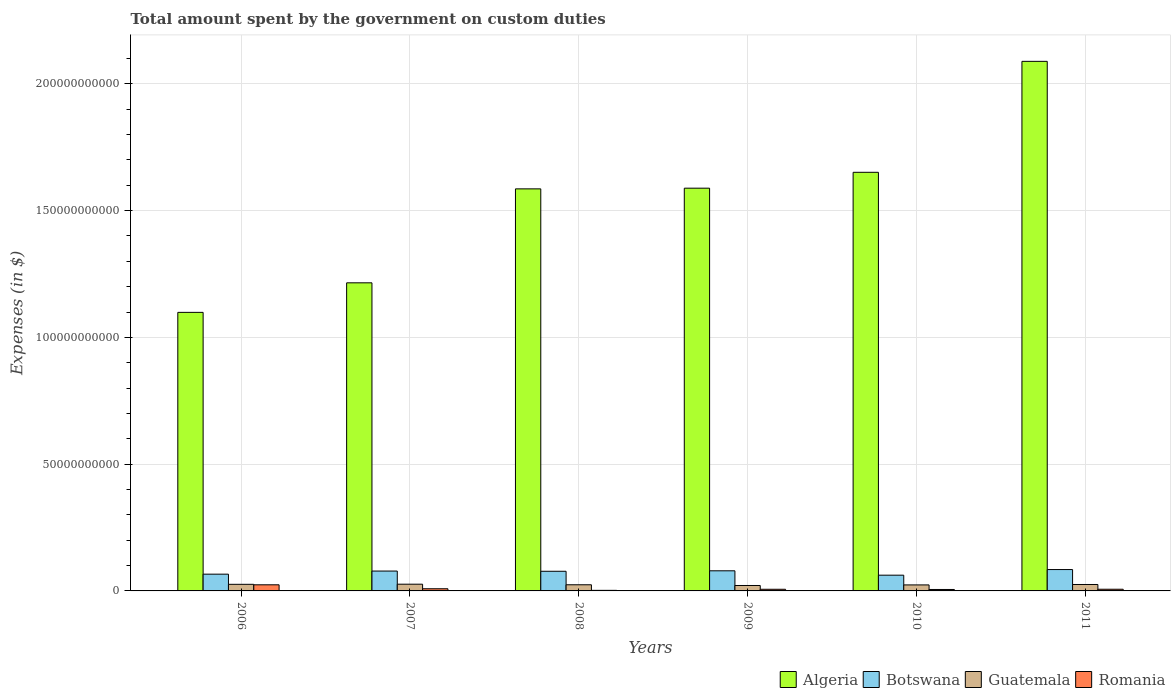How many different coloured bars are there?
Keep it short and to the point. 4. Are the number of bars per tick equal to the number of legend labels?
Give a very brief answer. Yes. How many bars are there on the 6th tick from the left?
Provide a succinct answer. 4. What is the label of the 4th group of bars from the left?
Your answer should be very brief. 2009. What is the amount spent on custom duties by the government in Guatemala in 2011?
Make the answer very short. 2.53e+09. Across all years, what is the maximum amount spent on custom duties by the government in Romania?
Keep it short and to the point. 2.41e+09. Across all years, what is the minimum amount spent on custom duties by the government in Algeria?
Ensure brevity in your answer.  1.10e+11. In which year was the amount spent on custom duties by the government in Botswana maximum?
Your answer should be very brief. 2011. What is the total amount spent on custom duties by the government in Algeria in the graph?
Offer a very short reply. 9.23e+11. What is the difference between the amount spent on custom duties by the government in Algeria in 2010 and that in 2011?
Offer a very short reply. -4.38e+1. What is the difference between the amount spent on custom duties by the government in Guatemala in 2011 and the amount spent on custom duties by the government in Algeria in 2006?
Provide a short and direct response. -1.07e+11. What is the average amount spent on custom duties by the government in Botswana per year?
Make the answer very short. 7.46e+09. In the year 2008, what is the difference between the amount spent on custom duties by the government in Guatemala and amount spent on custom duties by the government in Algeria?
Offer a very short reply. -1.56e+11. What is the ratio of the amount spent on custom duties by the government in Romania in 2008 to that in 2009?
Provide a succinct answer. 0.35. Is the amount spent on custom duties by the government in Algeria in 2006 less than that in 2009?
Your answer should be compact. Yes. What is the difference between the highest and the second highest amount spent on custom duties by the government in Algeria?
Give a very brief answer. 4.38e+1. What is the difference between the highest and the lowest amount spent on custom duties by the government in Botswana?
Keep it short and to the point. 2.22e+09. In how many years, is the amount spent on custom duties by the government in Guatemala greater than the average amount spent on custom duties by the government in Guatemala taken over all years?
Keep it short and to the point. 3. What does the 1st bar from the left in 2009 represents?
Provide a short and direct response. Algeria. What does the 1st bar from the right in 2010 represents?
Offer a very short reply. Romania. Is it the case that in every year, the sum of the amount spent on custom duties by the government in Botswana and amount spent on custom duties by the government in Romania is greater than the amount spent on custom duties by the government in Guatemala?
Provide a succinct answer. Yes. How many bars are there?
Provide a short and direct response. 24. Are all the bars in the graph horizontal?
Ensure brevity in your answer.  No. How many years are there in the graph?
Provide a short and direct response. 6. Are the values on the major ticks of Y-axis written in scientific E-notation?
Give a very brief answer. No. Does the graph contain grids?
Your answer should be compact. Yes. Where does the legend appear in the graph?
Keep it short and to the point. Bottom right. How many legend labels are there?
Provide a short and direct response. 4. What is the title of the graph?
Provide a succinct answer. Total amount spent by the government on custom duties. What is the label or title of the X-axis?
Offer a terse response. Years. What is the label or title of the Y-axis?
Ensure brevity in your answer.  Expenses (in $). What is the Expenses (in $) in Algeria in 2006?
Provide a succinct answer. 1.10e+11. What is the Expenses (in $) of Botswana in 2006?
Your answer should be compact. 6.61e+09. What is the Expenses (in $) in Guatemala in 2006?
Keep it short and to the point. 2.60e+09. What is the Expenses (in $) of Romania in 2006?
Your answer should be very brief. 2.41e+09. What is the Expenses (in $) in Algeria in 2007?
Provide a short and direct response. 1.22e+11. What is the Expenses (in $) in Botswana in 2007?
Give a very brief answer. 7.83e+09. What is the Expenses (in $) of Guatemala in 2007?
Ensure brevity in your answer.  2.65e+09. What is the Expenses (in $) of Romania in 2007?
Offer a terse response. 8.56e+08. What is the Expenses (in $) of Algeria in 2008?
Your answer should be compact. 1.59e+11. What is the Expenses (in $) in Botswana in 2008?
Provide a succinct answer. 7.75e+09. What is the Expenses (in $) in Guatemala in 2008?
Keep it short and to the point. 2.43e+09. What is the Expenses (in $) in Romania in 2008?
Offer a very short reply. 2.28e+08. What is the Expenses (in $) in Algeria in 2009?
Offer a terse response. 1.59e+11. What is the Expenses (in $) in Botswana in 2009?
Your answer should be compact. 7.93e+09. What is the Expenses (in $) in Guatemala in 2009?
Provide a short and direct response. 2.14e+09. What is the Expenses (in $) in Romania in 2009?
Your answer should be very brief. 6.50e+08. What is the Expenses (in $) of Algeria in 2010?
Provide a short and direct response. 1.65e+11. What is the Expenses (in $) in Botswana in 2010?
Give a very brief answer. 6.21e+09. What is the Expenses (in $) of Guatemala in 2010?
Keep it short and to the point. 2.37e+09. What is the Expenses (in $) in Romania in 2010?
Provide a short and direct response. 5.69e+08. What is the Expenses (in $) in Algeria in 2011?
Provide a short and direct response. 2.09e+11. What is the Expenses (in $) in Botswana in 2011?
Your answer should be very brief. 8.42e+09. What is the Expenses (in $) of Guatemala in 2011?
Give a very brief answer. 2.53e+09. What is the Expenses (in $) of Romania in 2011?
Offer a very short reply. 6.61e+08. Across all years, what is the maximum Expenses (in $) of Algeria?
Provide a short and direct response. 2.09e+11. Across all years, what is the maximum Expenses (in $) in Botswana?
Provide a short and direct response. 8.42e+09. Across all years, what is the maximum Expenses (in $) in Guatemala?
Keep it short and to the point. 2.65e+09. Across all years, what is the maximum Expenses (in $) in Romania?
Your response must be concise. 2.41e+09. Across all years, what is the minimum Expenses (in $) in Algeria?
Give a very brief answer. 1.10e+11. Across all years, what is the minimum Expenses (in $) of Botswana?
Your answer should be very brief. 6.21e+09. Across all years, what is the minimum Expenses (in $) of Guatemala?
Give a very brief answer. 2.14e+09. Across all years, what is the minimum Expenses (in $) in Romania?
Offer a terse response. 2.28e+08. What is the total Expenses (in $) of Algeria in the graph?
Offer a terse response. 9.23e+11. What is the total Expenses (in $) in Botswana in the graph?
Provide a short and direct response. 4.48e+1. What is the total Expenses (in $) in Guatemala in the graph?
Make the answer very short. 1.47e+1. What is the total Expenses (in $) in Romania in the graph?
Offer a terse response. 5.38e+09. What is the difference between the Expenses (in $) of Algeria in 2006 and that in 2007?
Ensure brevity in your answer.  -1.16e+1. What is the difference between the Expenses (in $) of Botswana in 2006 and that in 2007?
Make the answer very short. -1.22e+09. What is the difference between the Expenses (in $) in Guatemala in 2006 and that in 2007?
Keep it short and to the point. -5.04e+07. What is the difference between the Expenses (in $) in Romania in 2006 and that in 2007?
Ensure brevity in your answer.  1.56e+09. What is the difference between the Expenses (in $) in Algeria in 2006 and that in 2008?
Your answer should be compact. -4.87e+1. What is the difference between the Expenses (in $) in Botswana in 2006 and that in 2008?
Keep it short and to the point. -1.14e+09. What is the difference between the Expenses (in $) of Guatemala in 2006 and that in 2008?
Provide a succinct answer. 1.76e+08. What is the difference between the Expenses (in $) in Romania in 2006 and that in 2008?
Ensure brevity in your answer.  2.19e+09. What is the difference between the Expenses (in $) in Algeria in 2006 and that in 2009?
Your answer should be very brief. -4.90e+1. What is the difference between the Expenses (in $) of Botswana in 2006 and that in 2009?
Your response must be concise. -1.32e+09. What is the difference between the Expenses (in $) of Guatemala in 2006 and that in 2009?
Keep it short and to the point. 4.65e+08. What is the difference between the Expenses (in $) in Romania in 2006 and that in 2009?
Your answer should be compact. 1.76e+09. What is the difference between the Expenses (in $) in Algeria in 2006 and that in 2010?
Provide a succinct answer. -5.52e+1. What is the difference between the Expenses (in $) of Botswana in 2006 and that in 2010?
Your answer should be compact. 4.04e+08. What is the difference between the Expenses (in $) in Guatemala in 2006 and that in 2010?
Offer a very short reply. 2.36e+08. What is the difference between the Expenses (in $) of Romania in 2006 and that in 2010?
Provide a succinct answer. 1.85e+09. What is the difference between the Expenses (in $) in Algeria in 2006 and that in 2011?
Provide a succinct answer. -9.90e+1. What is the difference between the Expenses (in $) in Botswana in 2006 and that in 2011?
Keep it short and to the point. -1.81e+09. What is the difference between the Expenses (in $) of Guatemala in 2006 and that in 2011?
Give a very brief answer. 7.09e+07. What is the difference between the Expenses (in $) of Romania in 2006 and that in 2011?
Offer a terse response. 1.75e+09. What is the difference between the Expenses (in $) in Algeria in 2007 and that in 2008?
Ensure brevity in your answer.  -3.71e+1. What is the difference between the Expenses (in $) of Botswana in 2007 and that in 2008?
Your answer should be very brief. 8.47e+07. What is the difference between the Expenses (in $) of Guatemala in 2007 and that in 2008?
Offer a very short reply. 2.27e+08. What is the difference between the Expenses (in $) of Romania in 2007 and that in 2008?
Provide a short and direct response. 6.28e+08. What is the difference between the Expenses (in $) in Algeria in 2007 and that in 2009?
Ensure brevity in your answer.  -3.73e+1. What is the difference between the Expenses (in $) in Botswana in 2007 and that in 2009?
Make the answer very short. -9.62e+07. What is the difference between the Expenses (in $) of Guatemala in 2007 and that in 2009?
Offer a very short reply. 5.15e+08. What is the difference between the Expenses (in $) in Romania in 2007 and that in 2009?
Provide a succinct answer. 2.05e+08. What is the difference between the Expenses (in $) in Algeria in 2007 and that in 2010?
Give a very brief answer. -4.36e+1. What is the difference between the Expenses (in $) in Botswana in 2007 and that in 2010?
Give a very brief answer. 1.63e+09. What is the difference between the Expenses (in $) in Guatemala in 2007 and that in 2010?
Your response must be concise. 2.86e+08. What is the difference between the Expenses (in $) in Romania in 2007 and that in 2010?
Your response must be concise. 2.87e+08. What is the difference between the Expenses (in $) of Algeria in 2007 and that in 2011?
Offer a terse response. -8.73e+1. What is the difference between the Expenses (in $) of Botswana in 2007 and that in 2011?
Offer a terse response. -5.89e+08. What is the difference between the Expenses (in $) in Guatemala in 2007 and that in 2011?
Offer a terse response. 1.21e+08. What is the difference between the Expenses (in $) in Romania in 2007 and that in 2011?
Provide a succinct answer. 1.95e+08. What is the difference between the Expenses (in $) of Algeria in 2008 and that in 2009?
Provide a short and direct response. -2.69e+08. What is the difference between the Expenses (in $) in Botswana in 2008 and that in 2009?
Give a very brief answer. -1.81e+08. What is the difference between the Expenses (in $) in Guatemala in 2008 and that in 2009?
Keep it short and to the point. 2.88e+08. What is the difference between the Expenses (in $) of Romania in 2008 and that in 2009?
Give a very brief answer. -4.23e+08. What is the difference between the Expenses (in $) in Algeria in 2008 and that in 2010?
Ensure brevity in your answer.  -6.53e+09. What is the difference between the Expenses (in $) in Botswana in 2008 and that in 2010?
Your response must be concise. 1.54e+09. What is the difference between the Expenses (in $) of Guatemala in 2008 and that in 2010?
Offer a terse response. 5.95e+07. What is the difference between the Expenses (in $) in Romania in 2008 and that in 2010?
Your answer should be very brief. -3.41e+08. What is the difference between the Expenses (in $) in Algeria in 2008 and that in 2011?
Give a very brief answer. -5.03e+1. What is the difference between the Expenses (in $) of Botswana in 2008 and that in 2011?
Make the answer very short. -6.74e+08. What is the difference between the Expenses (in $) in Guatemala in 2008 and that in 2011?
Your answer should be very brief. -1.05e+08. What is the difference between the Expenses (in $) of Romania in 2008 and that in 2011?
Keep it short and to the point. -4.33e+08. What is the difference between the Expenses (in $) in Algeria in 2009 and that in 2010?
Offer a terse response. -6.26e+09. What is the difference between the Expenses (in $) in Botswana in 2009 and that in 2010?
Provide a short and direct response. 1.72e+09. What is the difference between the Expenses (in $) of Guatemala in 2009 and that in 2010?
Your response must be concise. -2.29e+08. What is the difference between the Expenses (in $) in Romania in 2009 and that in 2010?
Ensure brevity in your answer.  8.18e+07. What is the difference between the Expenses (in $) of Algeria in 2009 and that in 2011?
Make the answer very short. -5.00e+1. What is the difference between the Expenses (in $) of Botswana in 2009 and that in 2011?
Make the answer very short. -4.93e+08. What is the difference between the Expenses (in $) in Guatemala in 2009 and that in 2011?
Your answer should be compact. -3.94e+08. What is the difference between the Expenses (in $) in Romania in 2009 and that in 2011?
Give a very brief answer. -1.02e+07. What is the difference between the Expenses (in $) in Algeria in 2010 and that in 2011?
Offer a terse response. -4.38e+1. What is the difference between the Expenses (in $) of Botswana in 2010 and that in 2011?
Offer a terse response. -2.22e+09. What is the difference between the Expenses (in $) in Guatemala in 2010 and that in 2011?
Provide a short and direct response. -1.65e+08. What is the difference between the Expenses (in $) in Romania in 2010 and that in 2011?
Give a very brief answer. -9.20e+07. What is the difference between the Expenses (in $) of Algeria in 2006 and the Expenses (in $) of Botswana in 2007?
Your response must be concise. 1.02e+11. What is the difference between the Expenses (in $) in Algeria in 2006 and the Expenses (in $) in Guatemala in 2007?
Offer a very short reply. 1.07e+11. What is the difference between the Expenses (in $) in Algeria in 2006 and the Expenses (in $) in Romania in 2007?
Give a very brief answer. 1.09e+11. What is the difference between the Expenses (in $) in Botswana in 2006 and the Expenses (in $) in Guatemala in 2007?
Your response must be concise. 3.96e+09. What is the difference between the Expenses (in $) of Botswana in 2006 and the Expenses (in $) of Romania in 2007?
Give a very brief answer. 5.75e+09. What is the difference between the Expenses (in $) of Guatemala in 2006 and the Expenses (in $) of Romania in 2007?
Provide a short and direct response. 1.75e+09. What is the difference between the Expenses (in $) in Algeria in 2006 and the Expenses (in $) in Botswana in 2008?
Provide a succinct answer. 1.02e+11. What is the difference between the Expenses (in $) in Algeria in 2006 and the Expenses (in $) in Guatemala in 2008?
Make the answer very short. 1.07e+11. What is the difference between the Expenses (in $) in Algeria in 2006 and the Expenses (in $) in Romania in 2008?
Keep it short and to the point. 1.10e+11. What is the difference between the Expenses (in $) of Botswana in 2006 and the Expenses (in $) of Guatemala in 2008?
Your response must be concise. 4.18e+09. What is the difference between the Expenses (in $) in Botswana in 2006 and the Expenses (in $) in Romania in 2008?
Offer a very short reply. 6.38e+09. What is the difference between the Expenses (in $) in Guatemala in 2006 and the Expenses (in $) in Romania in 2008?
Make the answer very short. 2.38e+09. What is the difference between the Expenses (in $) in Algeria in 2006 and the Expenses (in $) in Botswana in 2009?
Ensure brevity in your answer.  1.02e+11. What is the difference between the Expenses (in $) in Algeria in 2006 and the Expenses (in $) in Guatemala in 2009?
Your response must be concise. 1.08e+11. What is the difference between the Expenses (in $) of Algeria in 2006 and the Expenses (in $) of Romania in 2009?
Ensure brevity in your answer.  1.09e+11. What is the difference between the Expenses (in $) in Botswana in 2006 and the Expenses (in $) in Guatemala in 2009?
Give a very brief answer. 4.47e+09. What is the difference between the Expenses (in $) in Botswana in 2006 and the Expenses (in $) in Romania in 2009?
Offer a very short reply. 5.96e+09. What is the difference between the Expenses (in $) in Guatemala in 2006 and the Expenses (in $) in Romania in 2009?
Ensure brevity in your answer.  1.95e+09. What is the difference between the Expenses (in $) in Algeria in 2006 and the Expenses (in $) in Botswana in 2010?
Provide a short and direct response. 1.04e+11. What is the difference between the Expenses (in $) in Algeria in 2006 and the Expenses (in $) in Guatemala in 2010?
Your answer should be very brief. 1.07e+11. What is the difference between the Expenses (in $) in Algeria in 2006 and the Expenses (in $) in Romania in 2010?
Provide a succinct answer. 1.09e+11. What is the difference between the Expenses (in $) in Botswana in 2006 and the Expenses (in $) in Guatemala in 2010?
Offer a very short reply. 4.24e+09. What is the difference between the Expenses (in $) in Botswana in 2006 and the Expenses (in $) in Romania in 2010?
Keep it short and to the point. 6.04e+09. What is the difference between the Expenses (in $) of Guatemala in 2006 and the Expenses (in $) of Romania in 2010?
Ensure brevity in your answer.  2.03e+09. What is the difference between the Expenses (in $) in Algeria in 2006 and the Expenses (in $) in Botswana in 2011?
Give a very brief answer. 1.01e+11. What is the difference between the Expenses (in $) of Algeria in 2006 and the Expenses (in $) of Guatemala in 2011?
Ensure brevity in your answer.  1.07e+11. What is the difference between the Expenses (in $) of Algeria in 2006 and the Expenses (in $) of Romania in 2011?
Ensure brevity in your answer.  1.09e+11. What is the difference between the Expenses (in $) in Botswana in 2006 and the Expenses (in $) in Guatemala in 2011?
Offer a terse response. 4.08e+09. What is the difference between the Expenses (in $) in Botswana in 2006 and the Expenses (in $) in Romania in 2011?
Keep it short and to the point. 5.95e+09. What is the difference between the Expenses (in $) of Guatemala in 2006 and the Expenses (in $) of Romania in 2011?
Your response must be concise. 1.94e+09. What is the difference between the Expenses (in $) of Algeria in 2007 and the Expenses (in $) of Botswana in 2008?
Your answer should be compact. 1.14e+11. What is the difference between the Expenses (in $) in Algeria in 2007 and the Expenses (in $) in Guatemala in 2008?
Provide a succinct answer. 1.19e+11. What is the difference between the Expenses (in $) of Algeria in 2007 and the Expenses (in $) of Romania in 2008?
Ensure brevity in your answer.  1.21e+11. What is the difference between the Expenses (in $) of Botswana in 2007 and the Expenses (in $) of Guatemala in 2008?
Your response must be concise. 5.41e+09. What is the difference between the Expenses (in $) of Botswana in 2007 and the Expenses (in $) of Romania in 2008?
Offer a very short reply. 7.61e+09. What is the difference between the Expenses (in $) in Guatemala in 2007 and the Expenses (in $) in Romania in 2008?
Keep it short and to the point. 2.43e+09. What is the difference between the Expenses (in $) of Algeria in 2007 and the Expenses (in $) of Botswana in 2009?
Your answer should be compact. 1.14e+11. What is the difference between the Expenses (in $) of Algeria in 2007 and the Expenses (in $) of Guatemala in 2009?
Keep it short and to the point. 1.19e+11. What is the difference between the Expenses (in $) of Algeria in 2007 and the Expenses (in $) of Romania in 2009?
Provide a short and direct response. 1.21e+11. What is the difference between the Expenses (in $) of Botswana in 2007 and the Expenses (in $) of Guatemala in 2009?
Provide a short and direct response. 5.70e+09. What is the difference between the Expenses (in $) in Botswana in 2007 and the Expenses (in $) in Romania in 2009?
Ensure brevity in your answer.  7.18e+09. What is the difference between the Expenses (in $) of Guatemala in 2007 and the Expenses (in $) of Romania in 2009?
Keep it short and to the point. 2.00e+09. What is the difference between the Expenses (in $) in Algeria in 2007 and the Expenses (in $) in Botswana in 2010?
Make the answer very short. 1.15e+11. What is the difference between the Expenses (in $) of Algeria in 2007 and the Expenses (in $) of Guatemala in 2010?
Your answer should be compact. 1.19e+11. What is the difference between the Expenses (in $) in Algeria in 2007 and the Expenses (in $) in Romania in 2010?
Provide a short and direct response. 1.21e+11. What is the difference between the Expenses (in $) in Botswana in 2007 and the Expenses (in $) in Guatemala in 2010?
Keep it short and to the point. 5.47e+09. What is the difference between the Expenses (in $) of Botswana in 2007 and the Expenses (in $) of Romania in 2010?
Offer a terse response. 7.27e+09. What is the difference between the Expenses (in $) of Guatemala in 2007 and the Expenses (in $) of Romania in 2010?
Your answer should be compact. 2.09e+09. What is the difference between the Expenses (in $) in Algeria in 2007 and the Expenses (in $) in Botswana in 2011?
Offer a very short reply. 1.13e+11. What is the difference between the Expenses (in $) in Algeria in 2007 and the Expenses (in $) in Guatemala in 2011?
Offer a terse response. 1.19e+11. What is the difference between the Expenses (in $) in Algeria in 2007 and the Expenses (in $) in Romania in 2011?
Give a very brief answer. 1.21e+11. What is the difference between the Expenses (in $) of Botswana in 2007 and the Expenses (in $) of Guatemala in 2011?
Your answer should be compact. 5.30e+09. What is the difference between the Expenses (in $) in Botswana in 2007 and the Expenses (in $) in Romania in 2011?
Offer a terse response. 7.17e+09. What is the difference between the Expenses (in $) of Guatemala in 2007 and the Expenses (in $) of Romania in 2011?
Your answer should be compact. 1.99e+09. What is the difference between the Expenses (in $) of Algeria in 2008 and the Expenses (in $) of Botswana in 2009?
Offer a terse response. 1.51e+11. What is the difference between the Expenses (in $) of Algeria in 2008 and the Expenses (in $) of Guatemala in 2009?
Make the answer very short. 1.56e+11. What is the difference between the Expenses (in $) of Algeria in 2008 and the Expenses (in $) of Romania in 2009?
Your answer should be very brief. 1.58e+11. What is the difference between the Expenses (in $) in Botswana in 2008 and the Expenses (in $) in Guatemala in 2009?
Your answer should be compact. 5.61e+09. What is the difference between the Expenses (in $) of Botswana in 2008 and the Expenses (in $) of Romania in 2009?
Provide a succinct answer. 7.10e+09. What is the difference between the Expenses (in $) in Guatemala in 2008 and the Expenses (in $) in Romania in 2009?
Provide a short and direct response. 1.78e+09. What is the difference between the Expenses (in $) of Algeria in 2008 and the Expenses (in $) of Botswana in 2010?
Keep it short and to the point. 1.52e+11. What is the difference between the Expenses (in $) of Algeria in 2008 and the Expenses (in $) of Guatemala in 2010?
Provide a succinct answer. 1.56e+11. What is the difference between the Expenses (in $) of Algeria in 2008 and the Expenses (in $) of Romania in 2010?
Provide a short and direct response. 1.58e+11. What is the difference between the Expenses (in $) of Botswana in 2008 and the Expenses (in $) of Guatemala in 2010?
Offer a very short reply. 5.38e+09. What is the difference between the Expenses (in $) of Botswana in 2008 and the Expenses (in $) of Romania in 2010?
Provide a succinct answer. 7.18e+09. What is the difference between the Expenses (in $) of Guatemala in 2008 and the Expenses (in $) of Romania in 2010?
Make the answer very short. 1.86e+09. What is the difference between the Expenses (in $) of Algeria in 2008 and the Expenses (in $) of Botswana in 2011?
Your answer should be compact. 1.50e+11. What is the difference between the Expenses (in $) of Algeria in 2008 and the Expenses (in $) of Guatemala in 2011?
Keep it short and to the point. 1.56e+11. What is the difference between the Expenses (in $) of Algeria in 2008 and the Expenses (in $) of Romania in 2011?
Offer a terse response. 1.58e+11. What is the difference between the Expenses (in $) of Botswana in 2008 and the Expenses (in $) of Guatemala in 2011?
Make the answer very short. 5.22e+09. What is the difference between the Expenses (in $) in Botswana in 2008 and the Expenses (in $) in Romania in 2011?
Your response must be concise. 7.09e+09. What is the difference between the Expenses (in $) of Guatemala in 2008 and the Expenses (in $) of Romania in 2011?
Make the answer very short. 1.77e+09. What is the difference between the Expenses (in $) in Algeria in 2009 and the Expenses (in $) in Botswana in 2010?
Give a very brief answer. 1.53e+11. What is the difference between the Expenses (in $) in Algeria in 2009 and the Expenses (in $) in Guatemala in 2010?
Your answer should be very brief. 1.56e+11. What is the difference between the Expenses (in $) in Algeria in 2009 and the Expenses (in $) in Romania in 2010?
Your answer should be very brief. 1.58e+11. What is the difference between the Expenses (in $) of Botswana in 2009 and the Expenses (in $) of Guatemala in 2010?
Your answer should be compact. 5.56e+09. What is the difference between the Expenses (in $) in Botswana in 2009 and the Expenses (in $) in Romania in 2010?
Provide a succinct answer. 7.36e+09. What is the difference between the Expenses (in $) in Guatemala in 2009 and the Expenses (in $) in Romania in 2010?
Your answer should be very brief. 1.57e+09. What is the difference between the Expenses (in $) of Algeria in 2009 and the Expenses (in $) of Botswana in 2011?
Ensure brevity in your answer.  1.50e+11. What is the difference between the Expenses (in $) of Algeria in 2009 and the Expenses (in $) of Guatemala in 2011?
Give a very brief answer. 1.56e+11. What is the difference between the Expenses (in $) of Algeria in 2009 and the Expenses (in $) of Romania in 2011?
Keep it short and to the point. 1.58e+11. What is the difference between the Expenses (in $) of Botswana in 2009 and the Expenses (in $) of Guatemala in 2011?
Your answer should be compact. 5.40e+09. What is the difference between the Expenses (in $) of Botswana in 2009 and the Expenses (in $) of Romania in 2011?
Make the answer very short. 7.27e+09. What is the difference between the Expenses (in $) in Guatemala in 2009 and the Expenses (in $) in Romania in 2011?
Your answer should be very brief. 1.48e+09. What is the difference between the Expenses (in $) in Algeria in 2010 and the Expenses (in $) in Botswana in 2011?
Make the answer very short. 1.57e+11. What is the difference between the Expenses (in $) in Algeria in 2010 and the Expenses (in $) in Guatemala in 2011?
Provide a succinct answer. 1.63e+11. What is the difference between the Expenses (in $) in Algeria in 2010 and the Expenses (in $) in Romania in 2011?
Keep it short and to the point. 1.64e+11. What is the difference between the Expenses (in $) of Botswana in 2010 and the Expenses (in $) of Guatemala in 2011?
Give a very brief answer. 3.67e+09. What is the difference between the Expenses (in $) of Botswana in 2010 and the Expenses (in $) of Romania in 2011?
Provide a succinct answer. 5.55e+09. What is the difference between the Expenses (in $) of Guatemala in 2010 and the Expenses (in $) of Romania in 2011?
Provide a short and direct response. 1.71e+09. What is the average Expenses (in $) of Algeria per year?
Your answer should be very brief. 1.54e+11. What is the average Expenses (in $) of Botswana per year?
Provide a succinct answer. 7.46e+09. What is the average Expenses (in $) of Guatemala per year?
Give a very brief answer. 2.45e+09. What is the average Expenses (in $) in Romania per year?
Ensure brevity in your answer.  8.96e+08. In the year 2006, what is the difference between the Expenses (in $) of Algeria and Expenses (in $) of Botswana?
Offer a terse response. 1.03e+11. In the year 2006, what is the difference between the Expenses (in $) of Algeria and Expenses (in $) of Guatemala?
Provide a short and direct response. 1.07e+11. In the year 2006, what is the difference between the Expenses (in $) in Algeria and Expenses (in $) in Romania?
Ensure brevity in your answer.  1.07e+11. In the year 2006, what is the difference between the Expenses (in $) in Botswana and Expenses (in $) in Guatemala?
Keep it short and to the point. 4.01e+09. In the year 2006, what is the difference between the Expenses (in $) of Botswana and Expenses (in $) of Romania?
Keep it short and to the point. 4.20e+09. In the year 2006, what is the difference between the Expenses (in $) of Guatemala and Expenses (in $) of Romania?
Give a very brief answer. 1.89e+08. In the year 2007, what is the difference between the Expenses (in $) in Algeria and Expenses (in $) in Botswana?
Your response must be concise. 1.14e+11. In the year 2007, what is the difference between the Expenses (in $) in Algeria and Expenses (in $) in Guatemala?
Give a very brief answer. 1.19e+11. In the year 2007, what is the difference between the Expenses (in $) of Algeria and Expenses (in $) of Romania?
Keep it short and to the point. 1.21e+11. In the year 2007, what is the difference between the Expenses (in $) of Botswana and Expenses (in $) of Guatemala?
Your response must be concise. 5.18e+09. In the year 2007, what is the difference between the Expenses (in $) in Botswana and Expenses (in $) in Romania?
Provide a short and direct response. 6.98e+09. In the year 2007, what is the difference between the Expenses (in $) in Guatemala and Expenses (in $) in Romania?
Your answer should be compact. 1.80e+09. In the year 2008, what is the difference between the Expenses (in $) in Algeria and Expenses (in $) in Botswana?
Offer a terse response. 1.51e+11. In the year 2008, what is the difference between the Expenses (in $) in Algeria and Expenses (in $) in Guatemala?
Provide a short and direct response. 1.56e+11. In the year 2008, what is the difference between the Expenses (in $) of Algeria and Expenses (in $) of Romania?
Ensure brevity in your answer.  1.58e+11. In the year 2008, what is the difference between the Expenses (in $) in Botswana and Expenses (in $) in Guatemala?
Provide a short and direct response. 5.32e+09. In the year 2008, what is the difference between the Expenses (in $) of Botswana and Expenses (in $) of Romania?
Provide a succinct answer. 7.52e+09. In the year 2008, what is the difference between the Expenses (in $) in Guatemala and Expenses (in $) in Romania?
Your answer should be very brief. 2.20e+09. In the year 2009, what is the difference between the Expenses (in $) of Algeria and Expenses (in $) of Botswana?
Your response must be concise. 1.51e+11. In the year 2009, what is the difference between the Expenses (in $) of Algeria and Expenses (in $) of Guatemala?
Make the answer very short. 1.57e+11. In the year 2009, what is the difference between the Expenses (in $) in Algeria and Expenses (in $) in Romania?
Your response must be concise. 1.58e+11. In the year 2009, what is the difference between the Expenses (in $) of Botswana and Expenses (in $) of Guatemala?
Offer a terse response. 5.79e+09. In the year 2009, what is the difference between the Expenses (in $) in Botswana and Expenses (in $) in Romania?
Offer a very short reply. 7.28e+09. In the year 2009, what is the difference between the Expenses (in $) in Guatemala and Expenses (in $) in Romania?
Give a very brief answer. 1.49e+09. In the year 2010, what is the difference between the Expenses (in $) of Algeria and Expenses (in $) of Botswana?
Make the answer very short. 1.59e+11. In the year 2010, what is the difference between the Expenses (in $) in Algeria and Expenses (in $) in Guatemala?
Your answer should be compact. 1.63e+11. In the year 2010, what is the difference between the Expenses (in $) of Algeria and Expenses (in $) of Romania?
Offer a very short reply. 1.65e+11. In the year 2010, what is the difference between the Expenses (in $) in Botswana and Expenses (in $) in Guatemala?
Your response must be concise. 3.84e+09. In the year 2010, what is the difference between the Expenses (in $) of Botswana and Expenses (in $) of Romania?
Offer a terse response. 5.64e+09. In the year 2010, what is the difference between the Expenses (in $) of Guatemala and Expenses (in $) of Romania?
Your answer should be compact. 1.80e+09. In the year 2011, what is the difference between the Expenses (in $) of Algeria and Expenses (in $) of Botswana?
Your response must be concise. 2.00e+11. In the year 2011, what is the difference between the Expenses (in $) of Algeria and Expenses (in $) of Guatemala?
Provide a succinct answer. 2.06e+11. In the year 2011, what is the difference between the Expenses (in $) of Algeria and Expenses (in $) of Romania?
Keep it short and to the point. 2.08e+11. In the year 2011, what is the difference between the Expenses (in $) of Botswana and Expenses (in $) of Guatemala?
Your answer should be compact. 5.89e+09. In the year 2011, what is the difference between the Expenses (in $) of Botswana and Expenses (in $) of Romania?
Keep it short and to the point. 7.76e+09. In the year 2011, what is the difference between the Expenses (in $) of Guatemala and Expenses (in $) of Romania?
Your answer should be very brief. 1.87e+09. What is the ratio of the Expenses (in $) in Algeria in 2006 to that in 2007?
Make the answer very short. 0.9. What is the ratio of the Expenses (in $) of Botswana in 2006 to that in 2007?
Provide a succinct answer. 0.84. What is the ratio of the Expenses (in $) in Guatemala in 2006 to that in 2007?
Your answer should be very brief. 0.98. What is the ratio of the Expenses (in $) of Romania in 2006 to that in 2007?
Offer a very short reply. 2.82. What is the ratio of the Expenses (in $) of Algeria in 2006 to that in 2008?
Make the answer very short. 0.69. What is the ratio of the Expenses (in $) of Botswana in 2006 to that in 2008?
Provide a succinct answer. 0.85. What is the ratio of the Expenses (in $) in Guatemala in 2006 to that in 2008?
Your response must be concise. 1.07. What is the ratio of the Expenses (in $) in Romania in 2006 to that in 2008?
Keep it short and to the point. 10.6. What is the ratio of the Expenses (in $) in Algeria in 2006 to that in 2009?
Provide a succinct answer. 0.69. What is the ratio of the Expenses (in $) of Botswana in 2006 to that in 2009?
Your response must be concise. 0.83. What is the ratio of the Expenses (in $) in Guatemala in 2006 to that in 2009?
Give a very brief answer. 1.22. What is the ratio of the Expenses (in $) in Romania in 2006 to that in 2009?
Offer a very short reply. 3.71. What is the ratio of the Expenses (in $) in Algeria in 2006 to that in 2010?
Your answer should be very brief. 0.67. What is the ratio of the Expenses (in $) in Botswana in 2006 to that in 2010?
Give a very brief answer. 1.07. What is the ratio of the Expenses (in $) in Guatemala in 2006 to that in 2010?
Your response must be concise. 1.1. What is the ratio of the Expenses (in $) in Romania in 2006 to that in 2010?
Make the answer very short. 4.25. What is the ratio of the Expenses (in $) of Algeria in 2006 to that in 2011?
Provide a succinct answer. 0.53. What is the ratio of the Expenses (in $) of Botswana in 2006 to that in 2011?
Keep it short and to the point. 0.78. What is the ratio of the Expenses (in $) in Guatemala in 2006 to that in 2011?
Your answer should be very brief. 1.03. What is the ratio of the Expenses (in $) in Romania in 2006 to that in 2011?
Ensure brevity in your answer.  3.66. What is the ratio of the Expenses (in $) in Algeria in 2007 to that in 2008?
Your answer should be compact. 0.77. What is the ratio of the Expenses (in $) of Botswana in 2007 to that in 2008?
Provide a short and direct response. 1.01. What is the ratio of the Expenses (in $) in Guatemala in 2007 to that in 2008?
Give a very brief answer. 1.09. What is the ratio of the Expenses (in $) of Romania in 2007 to that in 2008?
Your answer should be very brief. 3.76. What is the ratio of the Expenses (in $) in Algeria in 2007 to that in 2009?
Your response must be concise. 0.77. What is the ratio of the Expenses (in $) in Botswana in 2007 to that in 2009?
Your answer should be compact. 0.99. What is the ratio of the Expenses (in $) in Guatemala in 2007 to that in 2009?
Your answer should be very brief. 1.24. What is the ratio of the Expenses (in $) in Romania in 2007 to that in 2009?
Ensure brevity in your answer.  1.32. What is the ratio of the Expenses (in $) of Algeria in 2007 to that in 2010?
Your answer should be compact. 0.74. What is the ratio of the Expenses (in $) in Botswana in 2007 to that in 2010?
Your answer should be very brief. 1.26. What is the ratio of the Expenses (in $) of Guatemala in 2007 to that in 2010?
Your answer should be very brief. 1.12. What is the ratio of the Expenses (in $) of Romania in 2007 to that in 2010?
Your response must be concise. 1.5. What is the ratio of the Expenses (in $) in Algeria in 2007 to that in 2011?
Ensure brevity in your answer.  0.58. What is the ratio of the Expenses (in $) of Guatemala in 2007 to that in 2011?
Offer a terse response. 1.05. What is the ratio of the Expenses (in $) in Romania in 2007 to that in 2011?
Offer a very short reply. 1.3. What is the ratio of the Expenses (in $) in Algeria in 2008 to that in 2009?
Your answer should be compact. 1. What is the ratio of the Expenses (in $) of Botswana in 2008 to that in 2009?
Keep it short and to the point. 0.98. What is the ratio of the Expenses (in $) in Guatemala in 2008 to that in 2009?
Offer a very short reply. 1.13. What is the ratio of the Expenses (in $) of Romania in 2008 to that in 2009?
Offer a terse response. 0.35. What is the ratio of the Expenses (in $) of Algeria in 2008 to that in 2010?
Ensure brevity in your answer.  0.96. What is the ratio of the Expenses (in $) of Botswana in 2008 to that in 2010?
Give a very brief answer. 1.25. What is the ratio of the Expenses (in $) in Guatemala in 2008 to that in 2010?
Keep it short and to the point. 1.03. What is the ratio of the Expenses (in $) of Romania in 2008 to that in 2010?
Ensure brevity in your answer.  0.4. What is the ratio of the Expenses (in $) of Algeria in 2008 to that in 2011?
Offer a very short reply. 0.76. What is the ratio of the Expenses (in $) in Botswana in 2008 to that in 2011?
Offer a very short reply. 0.92. What is the ratio of the Expenses (in $) in Guatemala in 2008 to that in 2011?
Offer a terse response. 0.96. What is the ratio of the Expenses (in $) in Romania in 2008 to that in 2011?
Make the answer very short. 0.34. What is the ratio of the Expenses (in $) of Algeria in 2009 to that in 2010?
Offer a terse response. 0.96. What is the ratio of the Expenses (in $) in Botswana in 2009 to that in 2010?
Make the answer very short. 1.28. What is the ratio of the Expenses (in $) in Guatemala in 2009 to that in 2010?
Make the answer very short. 0.9. What is the ratio of the Expenses (in $) in Romania in 2009 to that in 2010?
Offer a very short reply. 1.14. What is the ratio of the Expenses (in $) of Algeria in 2009 to that in 2011?
Your response must be concise. 0.76. What is the ratio of the Expenses (in $) of Botswana in 2009 to that in 2011?
Give a very brief answer. 0.94. What is the ratio of the Expenses (in $) in Guatemala in 2009 to that in 2011?
Give a very brief answer. 0.84. What is the ratio of the Expenses (in $) of Romania in 2009 to that in 2011?
Offer a very short reply. 0.98. What is the ratio of the Expenses (in $) in Algeria in 2010 to that in 2011?
Offer a very short reply. 0.79. What is the ratio of the Expenses (in $) of Botswana in 2010 to that in 2011?
Ensure brevity in your answer.  0.74. What is the ratio of the Expenses (in $) in Guatemala in 2010 to that in 2011?
Give a very brief answer. 0.93. What is the ratio of the Expenses (in $) in Romania in 2010 to that in 2011?
Keep it short and to the point. 0.86. What is the difference between the highest and the second highest Expenses (in $) of Algeria?
Your answer should be very brief. 4.38e+1. What is the difference between the highest and the second highest Expenses (in $) in Botswana?
Offer a very short reply. 4.93e+08. What is the difference between the highest and the second highest Expenses (in $) in Guatemala?
Give a very brief answer. 5.04e+07. What is the difference between the highest and the second highest Expenses (in $) in Romania?
Ensure brevity in your answer.  1.56e+09. What is the difference between the highest and the lowest Expenses (in $) in Algeria?
Keep it short and to the point. 9.90e+1. What is the difference between the highest and the lowest Expenses (in $) of Botswana?
Offer a very short reply. 2.22e+09. What is the difference between the highest and the lowest Expenses (in $) of Guatemala?
Keep it short and to the point. 5.15e+08. What is the difference between the highest and the lowest Expenses (in $) of Romania?
Make the answer very short. 2.19e+09. 